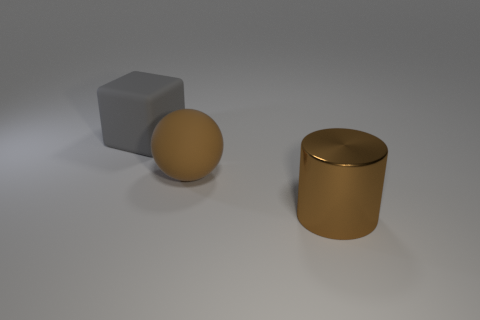There is a shiny cylinder; does it have the same color as the rubber thing right of the big matte block?
Keep it short and to the point. Yes. What shape is the large metal object that is the same color as the large sphere?
Offer a very short reply. Cylinder. How many large matte spheres are the same color as the large metallic thing?
Make the answer very short. 1. Is the material of the large brown object behind the metal cylinder the same as the cylinder?
Your response must be concise. No. There is a thing that is both behind the cylinder and on the right side of the large rubber block; what color is it?
Provide a succinct answer. Brown. There is a rubber object that is in front of the rubber cube; what number of things are behind it?
Provide a short and direct response. 1. The ball is what color?
Offer a terse response. Brown. How many things are either brown spheres or small cyan shiny spheres?
Make the answer very short. 1. The big thing in front of the matte thing that is in front of the gray rubber thing is what shape?
Make the answer very short. Cylinder. What number of other objects are there of the same material as the big gray object?
Your answer should be compact. 1. 